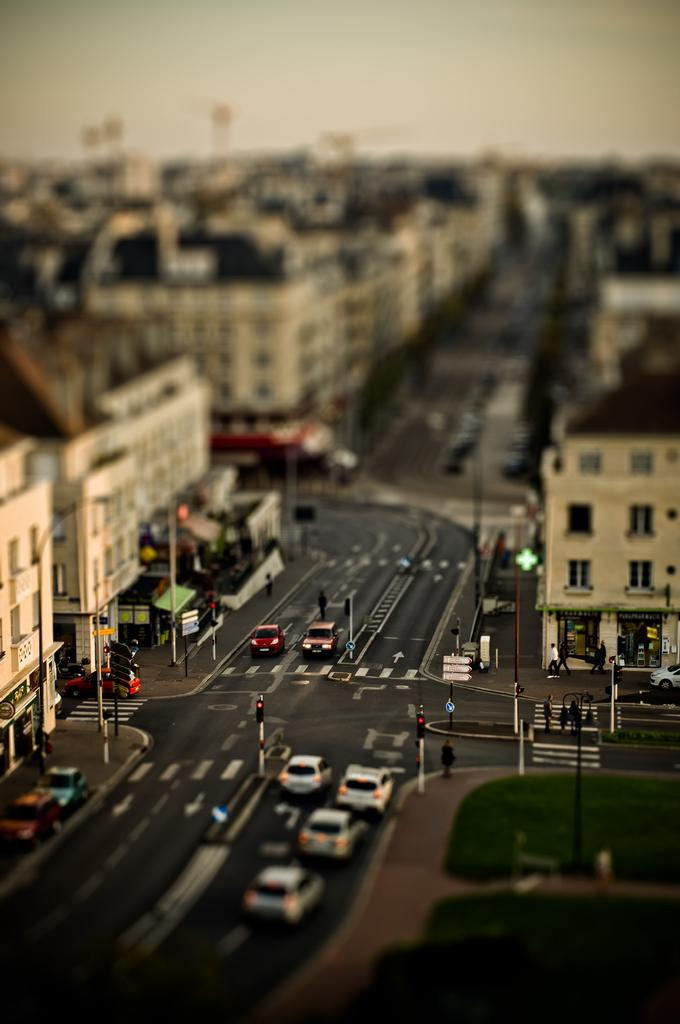What type of view is shown in the image? The image is an aerial view. What can be seen on the ground in the image? There are vehicles on the road and poles ones on the road in the image. What is located on either side of the road in the image? There are buildings on either side of the road in the image. What is visible at the top of the image? The sky is visible at the top of the image. Are there any beads or quicksand visible in the image? No, there are no beads or quicksand present in the image. Is there a farm visible in the image? No, there is no farm visible in the image. 